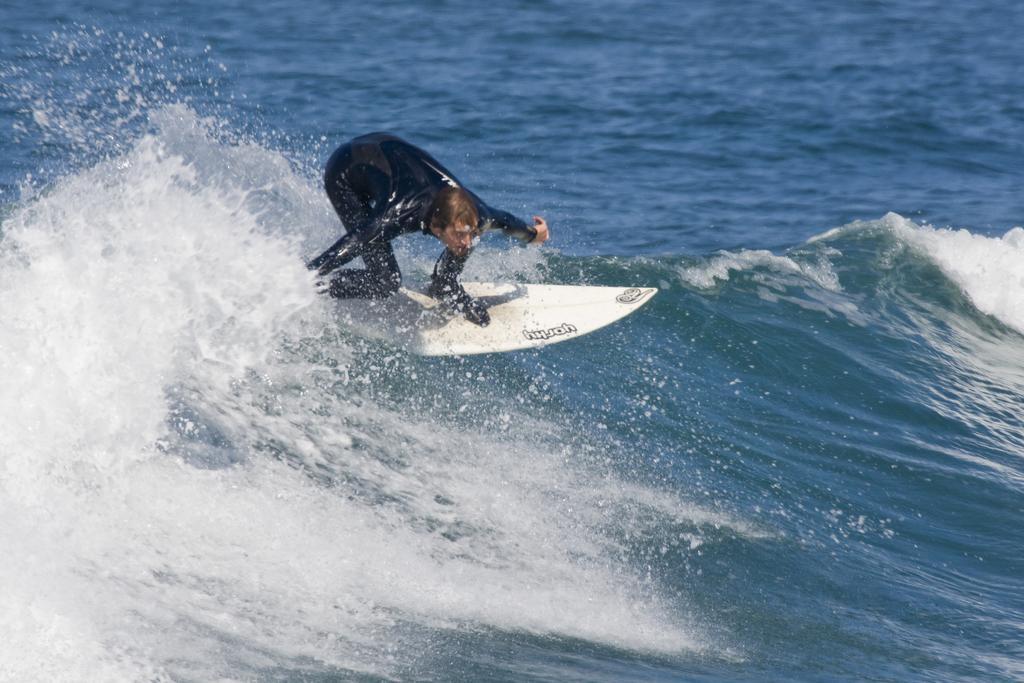Could you give a brief overview of what you see in this image? As we can see in the image there is water, a man wearing black color swimsuit and surfing. 